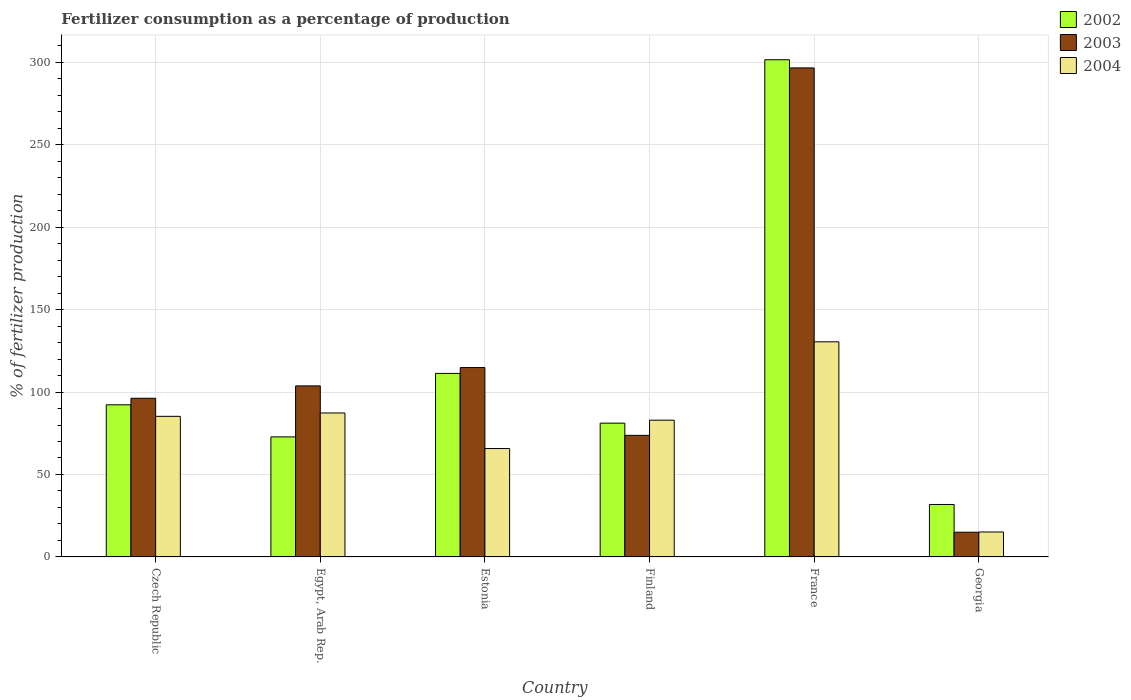How many different coloured bars are there?
Make the answer very short. 3. How many groups of bars are there?
Give a very brief answer. 6. Are the number of bars per tick equal to the number of legend labels?
Provide a succinct answer. Yes. Are the number of bars on each tick of the X-axis equal?
Your answer should be very brief. Yes. How many bars are there on the 1st tick from the left?
Provide a succinct answer. 3. What is the label of the 1st group of bars from the left?
Your response must be concise. Czech Republic. In how many cases, is the number of bars for a given country not equal to the number of legend labels?
Provide a succinct answer. 0. What is the percentage of fertilizers consumed in 2004 in Georgia?
Provide a succinct answer. 15.12. Across all countries, what is the maximum percentage of fertilizers consumed in 2004?
Offer a terse response. 130.46. Across all countries, what is the minimum percentage of fertilizers consumed in 2004?
Offer a very short reply. 15.12. In which country was the percentage of fertilizers consumed in 2002 maximum?
Provide a succinct answer. France. In which country was the percentage of fertilizers consumed in 2003 minimum?
Make the answer very short. Georgia. What is the total percentage of fertilizers consumed in 2002 in the graph?
Give a very brief answer. 690.84. What is the difference between the percentage of fertilizers consumed in 2003 in Egypt, Arab Rep. and that in Estonia?
Ensure brevity in your answer.  -11.13. What is the difference between the percentage of fertilizers consumed in 2004 in Czech Republic and the percentage of fertilizers consumed in 2003 in France?
Your answer should be compact. -211.3. What is the average percentage of fertilizers consumed in 2004 per country?
Your answer should be very brief. 77.8. What is the difference between the percentage of fertilizers consumed of/in 2004 and percentage of fertilizers consumed of/in 2002 in Finland?
Your answer should be very brief. 1.79. In how many countries, is the percentage of fertilizers consumed in 2004 greater than 280 %?
Your answer should be very brief. 0. What is the ratio of the percentage of fertilizers consumed in 2004 in Egypt, Arab Rep. to that in Estonia?
Make the answer very short. 1.33. What is the difference between the highest and the second highest percentage of fertilizers consumed in 2004?
Your response must be concise. 45.19. What is the difference between the highest and the lowest percentage of fertilizers consumed in 2002?
Your answer should be compact. 269.72. Is the sum of the percentage of fertilizers consumed in 2004 in Egypt, Arab Rep. and Finland greater than the maximum percentage of fertilizers consumed in 2003 across all countries?
Ensure brevity in your answer.  No. What does the 3rd bar from the left in Czech Republic represents?
Keep it short and to the point. 2004. What does the 3rd bar from the right in Czech Republic represents?
Offer a very short reply. 2002. Is it the case that in every country, the sum of the percentage of fertilizers consumed in 2002 and percentage of fertilizers consumed in 2003 is greater than the percentage of fertilizers consumed in 2004?
Offer a very short reply. Yes. Are all the bars in the graph horizontal?
Keep it short and to the point. No. How many countries are there in the graph?
Make the answer very short. 6. Are the values on the major ticks of Y-axis written in scientific E-notation?
Make the answer very short. No. Where does the legend appear in the graph?
Keep it short and to the point. Top right. How many legend labels are there?
Your response must be concise. 3. What is the title of the graph?
Offer a very short reply. Fertilizer consumption as a percentage of production. What is the label or title of the Y-axis?
Your response must be concise. % of fertilizer production. What is the % of fertilizer production of 2002 in Czech Republic?
Offer a terse response. 92.26. What is the % of fertilizer production of 2003 in Czech Republic?
Your answer should be very brief. 96.22. What is the % of fertilizer production in 2004 in Czech Republic?
Your answer should be very brief. 85.27. What is the % of fertilizer production of 2002 in Egypt, Arab Rep.?
Offer a very short reply. 72.8. What is the % of fertilizer production in 2003 in Egypt, Arab Rep.?
Make the answer very short. 103.72. What is the % of fertilizer production in 2004 in Egypt, Arab Rep.?
Ensure brevity in your answer.  87.3. What is the % of fertilizer production of 2002 in Estonia?
Make the answer very short. 111.3. What is the % of fertilizer production of 2003 in Estonia?
Offer a terse response. 114.85. What is the % of fertilizer production of 2004 in Estonia?
Provide a succinct answer. 65.74. What is the % of fertilizer production in 2002 in Finland?
Your answer should be compact. 81.14. What is the % of fertilizer production in 2003 in Finland?
Offer a very short reply. 73.73. What is the % of fertilizer production of 2004 in Finland?
Ensure brevity in your answer.  82.93. What is the % of fertilizer production of 2002 in France?
Offer a very short reply. 301.53. What is the % of fertilizer production in 2003 in France?
Your response must be concise. 296.56. What is the % of fertilizer production of 2004 in France?
Offer a terse response. 130.46. What is the % of fertilizer production of 2002 in Georgia?
Your answer should be compact. 31.81. What is the % of fertilizer production of 2003 in Georgia?
Make the answer very short. 14.99. What is the % of fertilizer production of 2004 in Georgia?
Offer a very short reply. 15.12. Across all countries, what is the maximum % of fertilizer production of 2002?
Your response must be concise. 301.53. Across all countries, what is the maximum % of fertilizer production of 2003?
Provide a short and direct response. 296.56. Across all countries, what is the maximum % of fertilizer production in 2004?
Your answer should be compact. 130.46. Across all countries, what is the minimum % of fertilizer production in 2002?
Give a very brief answer. 31.81. Across all countries, what is the minimum % of fertilizer production of 2003?
Offer a very short reply. 14.99. Across all countries, what is the minimum % of fertilizer production of 2004?
Give a very brief answer. 15.12. What is the total % of fertilizer production of 2002 in the graph?
Provide a succinct answer. 690.84. What is the total % of fertilizer production of 2003 in the graph?
Make the answer very short. 700.07. What is the total % of fertilizer production of 2004 in the graph?
Offer a terse response. 466.82. What is the difference between the % of fertilizer production of 2002 in Czech Republic and that in Egypt, Arab Rep.?
Provide a short and direct response. 19.47. What is the difference between the % of fertilizer production of 2003 in Czech Republic and that in Egypt, Arab Rep.?
Your answer should be compact. -7.5. What is the difference between the % of fertilizer production in 2004 in Czech Republic and that in Egypt, Arab Rep.?
Make the answer very short. -2.03. What is the difference between the % of fertilizer production in 2002 in Czech Republic and that in Estonia?
Offer a very short reply. -19.04. What is the difference between the % of fertilizer production of 2003 in Czech Republic and that in Estonia?
Offer a terse response. -18.63. What is the difference between the % of fertilizer production of 2004 in Czech Republic and that in Estonia?
Your answer should be very brief. 19.53. What is the difference between the % of fertilizer production of 2002 in Czech Republic and that in Finland?
Your answer should be compact. 11.12. What is the difference between the % of fertilizer production in 2003 in Czech Republic and that in Finland?
Your answer should be very brief. 22.49. What is the difference between the % of fertilizer production in 2004 in Czech Republic and that in Finland?
Give a very brief answer. 2.34. What is the difference between the % of fertilizer production of 2002 in Czech Republic and that in France?
Provide a short and direct response. -209.27. What is the difference between the % of fertilizer production in 2003 in Czech Republic and that in France?
Give a very brief answer. -200.34. What is the difference between the % of fertilizer production in 2004 in Czech Republic and that in France?
Your answer should be compact. -45.19. What is the difference between the % of fertilizer production in 2002 in Czech Republic and that in Georgia?
Your answer should be very brief. 60.45. What is the difference between the % of fertilizer production of 2003 in Czech Republic and that in Georgia?
Provide a succinct answer. 81.24. What is the difference between the % of fertilizer production of 2004 in Czech Republic and that in Georgia?
Make the answer very short. 70.15. What is the difference between the % of fertilizer production in 2002 in Egypt, Arab Rep. and that in Estonia?
Give a very brief answer. -38.51. What is the difference between the % of fertilizer production of 2003 in Egypt, Arab Rep. and that in Estonia?
Provide a succinct answer. -11.13. What is the difference between the % of fertilizer production in 2004 in Egypt, Arab Rep. and that in Estonia?
Your answer should be very brief. 21.56. What is the difference between the % of fertilizer production of 2002 in Egypt, Arab Rep. and that in Finland?
Ensure brevity in your answer.  -8.34. What is the difference between the % of fertilizer production of 2003 in Egypt, Arab Rep. and that in Finland?
Make the answer very short. 29.99. What is the difference between the % of fertilizer production in 2004 in Egypt, Arab Rep. and that in Finland?
Keep it short and to the point. 4.37. What is the difference between the % of fertilizer production of 2002 in Egypt, Arab Rep. and that in France?
Ensure brevity in your answer.  -228.73. What is the difference between the % of fertilizer production of 2003 in Egypt, Arab Rep. and that in France?
Give a very brief answer. -192.85. What is the difference between the % of fertilizer production in 2004 in Egypt, Arab Rep. and that in France?
Your answer should be compact. -43.16. What is the difference between the % of fertilizer production of 2002 in Egypt, Arab Rep. and that in Georgia?
Provide a short and direct response. 40.99. What is the difference between the % of fertilizer production of 2003 in Egypt, Arab Rep. and that in Georgia?
Offer a terse response. 88.73. What is the difference between the % of fertilizer production of 2004 in Egypt, Arab Rep. and that in Georgia?
Ensure brevity in your answer.  72.18. What is the difference between the % of fertilizer production of 2002 in Estonia and that in Finland?
Your answer should be very brief. 30.17. What is the difference between the % of fertilizer production in 2003 in Estonia and that in Finland?
Offer a very short reply. 41.12. What is the difference between the % of fertilizer production of 2004 in Estonia and that in Finland?
Provide a short and direct response. -17.19. What is the difference between the % of fertilizer production of 2002 in Estonia and that in France?
Offer a very short reply. -190.22. What is the difference between the % of fertilizer production in 2003 in Estonia and that in France?
Your answer should be very brief. -181.71. What is the difference between the % of fertilizer production in 2004 in Estonia and that in France?
Make the answer very short. -64.72. What is the difference between the % of fertilizer production of 2002 in Estonia and that in Georgia?
Offer a very short reply. 79.5. What is the difference between the % of fertilizer production of 2003 in Estonia and that in Georgia?
Offer a terse response. 99.86. What is the difference between the % of fertilizer production in 2004 in Estonia and that in Georgia?
Offer a very short reply. 50.62. What is the difference between the % of fertilizer production in 2002 in Finland and that in France?
Provide a succinct answer. -220.39. What is the difference between the % of fertilizer production in 2003 in Finland and that in France?
Your response must be concise. -222.83. What is the difference between the % of fertilizer production in 2004 in Finland and that in France?
Provide a short and direct response. -47.53. What is the difference between the % of fertilizer production in 2002 in Finland and that in Georgia?
Provide a succinct answer. 49.33. What is the difference between the % of fertilizer production of 2003 in Finland and that in Georgia?
Give a very brief answer. 58.75. What is the difference between the % of fertilizer production in 2004 in Finland and that in Georgia?
Provide a succinct answer. 67.81. What is the difference between the % of fertilizer production in 2002 in France and that in Georgia?
Provide a short and direct response. 269.72. What is the difference between the % of fertilizer production in 2003 in France and that in Georgia?
Provide a short and direct response. 281.58. What is the difference between the % of fertilizer production of 2004 in France and that in Georgia?
Give a very brief answer. 115.34. What is the difference between the % of fertilizer production of 2002 in Czech Republic and the % of fertilizer production of 2003 in Egypt, Arab Rep.?
Give a very brief answer. -11.46. What is the difference between the % of fertilizer production in 2002 in Czech Republic and the % of fertilizer production in 2004 in Egypt, Arab Rep.?
Give a very brief answer. 4.96. What is the difference between the % of fertilizer production of 2003 in Czech Republic and the % of fertilizer production of 2004 in Egypt, Arab Rep.?
Provide a succinct answer. 8.92. What is the difference between the % of fertilizer production of 2002 in Czech Republic and the % of fertilizer production of 2003 in Estonia?
Your answer should be compact. -22.59. What is the difference between the % of fertilizer production in 2002 in Czech Republic and the % of fertilizer production in 2004 in Estonia?
Your response must be concise. 26.52. What is the difference between the % of fertilizer production of 2003 in Czech Republic and the % of fertilizer production of 2004 in Estonia?
Ensure brevity in your answer.  30.48. What is the difference between the % of fertilizer production of 2002 in Czech Republic and the % of fertilizer production of 2003 in Finland?
Your answer should be compact. 18.53. What is the difference between the % of fertilizer production of 2002 in Czech Republic and the % of fertilizer production of 2004 in Finland?
Offer a very short reply. 9.33. What is the difference between the % of fertilizer production of 2003 in Czech Republic and the % of fertilizer production of 2004 in Finland?
Your response must be concise. 13.29. What is the difference between the % of fertilizer production of 2002 in Czech Republic and the % of fertilizer production of 2003 in France?
Give a very brief answer. -204.3. What is the difference between the % of fertilizer production of 2002 in Czech Republic and the % of fertilizer production of 2004 in France?
Give a very brief answer. -38.2. What is the difference between the % of fertilizer production of 2003 in Czech Republic and the % of fertilizer production of 2004 in France?
Your answer should be very brief. -34.24. What is the difference between the % of fertilizer production in 2002 in Czech Republic and the % of fertilizer production in 2003 in Georgia?
Provide a succinct answer. 77.28. What is the difference between the % of fertilizer production of 2002 in Czech Republic and the % of fertilizer production of 2004 in Georgia?
Provide a short and direct response. 77.14. What is the difference between the % of fertilizer production in 2003 in Czech Republic and the % of fertilizer production in 2004 in Georgia?
Offer a very short reply. 81.1. What is the difference between the % of fertilizer production of 2002 in Egypt, Arab Rep. and the % of fertilizer production of 2003 in Estonia?
Offer a terse response. -42.05. What is the difference between the % of fertilizer production of 2002 in Egypt, Arab Rep. and the % of fertilizer production of 2004 in Estonia?
Ensure brevity in your answer.  7.06. What is the difference between the % of fertilizer production of 2003 in Egypt, Arab Rep. and the % of fertilizer production of 2004 in Estonia?
Make the answer very short. 37.98. What is the difference between the % of fertilizer production in 2002 in Egypt, Arab Rep. and the % of fertilizer production in 2003 in Finland?
Ensure brevity in your answer.  -0.94. What is the difference between the % of fertilizer production in 2002 in Egypt, Arab Rep. and the % of fertilizer production in 2004 in Finland?
Provide a short and direct response. -10.14. What is the difference between the % of fertilizer production of 2003 in Egypt, Arab Rep. and the % of fertilizer production of 2004 in Finland?
Ensure brevity in your answer.  20.79. What is the difference between the % of fertilizer production in 2002 in Egypt, Arab Rep. and the % of fertilizer production in 2003 in France?
Ensure brevity in your answer.  -223.77. What is the difference between the % of fertilizer production in 2002 in Egypt, Arab Rep. and the % of fertilizer production in 2004 in France?
Your answer should be compact. -57.66. What is the difference between the % of fertilizer production of 2003 in Egypt, Arab Rep. and the % of fertilizer production of 2004 in France?
Offer a terse response. -26.74. What is the difference between the % of fertilizer production in 2002 in Egypt, Arab Rep. and the % of fertilizer production in 2003 in Georgia?
Offer a very short reply. 57.81. What is the difference between the % of fertilizer production in 2002 in Egypt, Arab Rep. and the % of fertilizer production in 2004 in Georgia?
Ensure brevity in your answer.  57.68. What is the difference between the % of fertilizer production of 2003 in Egypt, Arab Rep. and the % of fertilizer production of 2004 in Georgia?
Offer a very short reply. 88.6. What is the difference between the % of fertilizer production of 2002 in Estonia and the % of fertilizer production of 2003 in Finland?
Your answer should be compact. 37.57. What is the difference between the % of fertilizer production of 2002 in Estonia and the % of fertilizer production of 2004 in Finland?
Your answer should be compact. 28.37. What is the difference between the % of fertilizer production of 2003 in Estonia and the % of fertilizer production of 2004 in Finland?
Ensure brevity in your answer.  31.92. What is the difference between the % of fertilizer production of 2002 in Estonia and the % of fertilizer production of 2003 in France?
Keep it short and to the point. -185.26. What is the difference between the % of fertilizer production of 2002 in Estonia and the % of fertilizer production of 2004 in France?
Your answer should be compact. -19.16. What is the difference between the % of fertilizer production of 2003 in Estonia and the % of fertilizer production of 2004 in France?
Give a very brief answer. -15.61. What is the difference between the % of fertilizer production of 2002 in Estonia and the % of fertilizer production of 2003 in Georgia?
Offer a very short reply. 96.32. What is the difference between the % of fertilizer production of 2002 in Estonia and the % of fertilizer production of 2004 in Georgia?
Provide a succinct answer. 96.19. What is the difference between the % of fertilizer production of 2003 in Estonia and the % of fertilizer production of 2004 in Georgia?
Offer a very short reply. 99.73. What is the difference between the % of fertilizer production in 2002 in Finland and the % of fertilizer production in 2003 in France?
Your answer should be compact. -215.43. What is the difference between the % of fertilizer production of 2002 in Finland and the % of fertilizer production of 2004 in France?
Provide a succinct answer. -49.32. What is the difference between the % of fertilizer production of 2003 in Finland and the % of fertilizer production of 2004 in France?
Provide a short and direct response. -56.73. What is the difference between the % of fertilizer production of 2002 in Finland and the % of fertilizer production of 2003 in Georgia?
Your response must be concise. 66.15. What is the difference between the % of fertilizer production of 2002 in Finland and the % of fertilizer production of 2004 in Georgia?
Offer a terse response. 66.02. What is the difference between the % of fertilizer production of 2003 in Finland and the % of fertilizer production of 2004 in Georgia?
Give a very brief answer. 58.61. What is the difference between the % of fertilizer production in 2002 in France and the % of fertilizer production in 2003 in Georgia?
Ensure brevity in your answer.  286.54. What is the difference between the % of fertilizer production of 2002 in France and the % of fertilizer production of 2004 in Georgia?
Provide a short and direct response. 286.41. What is the difference between the % of fertilizer production in 2003 in France and the % of fertilizer production in 2004 in Georgia?
Your response must be concise. 281.45. What is the average % of fertilizer production in 2002 per country?
Make the answer very short. 115.14. What is the average % of fertilizer production of 2003 per country?
Offer a terse response. 116.68. What is the average % of fertilizer production of 2004 per country?
Your answer should be compact. 77.8. What is the difference between the % of fertilizer production of 2002 and % of fertilizer production of 2003 in Czech Republic?
Make the answer very short. -3.96. What is the difference between the % of fertilizer production of 2002 and % of fertilizer production of 2004 in Czech Republic?
Offer a very short reply. 6.99. What is the difference between the % of fertilizer production in 2003 and % of fertilizer production in 2004 in Czech Republic?
Provide a short and direct response. 10.95. What is the difference between the % of fertilizer production in 2002 and % of fertilizer production in 2003 in Egypt, Arab Rep.?
Make the answer very short. -30.92. What is the difference between the % of fertilizer production of 2002 and % of fertilizer production of 2004 in Egypt, Arab Rep.?
Your answer should be compact. -14.5. What is the difference between the % of fertilizer production in 2003 and % of fertilizer production in 2004 in Egypt, Arab Rep.?
Your response must be concise. 16.42. What is the difference between the % of fertilizer production of 2002 and % of fertilizer production of 2003 in Estonia?
Your response must be concise. -3.55. What is the difference between the % of fertilizer production of 2002 and % of fertilizer production of 2004 in Estonia?
Keep it short and to the point. 45.57. What is the difference between the % of fertilizer production of 2003 and % of fertilizer production of 2004 in Estonia?
Give a very brief answer. 49.11. What is the difference between the % of fertilizer production of 2002 and % of fertilizer production of 2003 in Finland?
Provide a succinct answer. 7.41. What is the difference between the % of fertilizer production in 2002 and % of fertilizer production in 2004 in Finland?
Ensure brevity in your answer.  -1.79. What is the difference between the % of fertilizer production of 2003 and % of fertilizer production of 2004 in Finland?
Offer a terse response. -9.2. What is the difference between the % of fertilizer production of 2002 and % of fertilizer production of 2003 in France?
Ensure brevity in your answer.  4.96. What is the difference between the % of fertilizer production of 2002 and % of fertilizer production of 2004 in France?
Offer a very short reply. 171.07. What is the difference between the % of fertilizer production of 2003 and % of fertilizer production of 2004 in France?
Your answer should be compact. 166.1. What is the difference between the % of fertilizer production of 2002 and % of fertilizer production of 2003 in Georgia?
Give a very brief answer. 16.82. What is the difference between the % of fertilizer production in 2002 and % of fertilizer production in 2004 in Georgia?
Your response must be concise. 16.69. What is the difference between the % of fertilizer production of 2003 and % of fertilizer production of 2004 in Georgia?
Ensure brevity in your answer.  -0.13. What is the ratio of the % of fertilizer production in 2002 in Czech Republic to that in Egypt, Arab Rep.?
Your response must be concise. 1.27. What is the ratio of the % of fertilizer production in 2003 in Czech Republic to that in Egypt, Arab Rep.?
Offer a very short reply. 0.93. What is the ratio of the % of fertilizer production in 2004 in Czech Republic to that in Egypt, Arab Rep.?
Make the answer very short. 0.98. What is the ratio of the % of fertilizer production of 2002 in Czech Republic to that in Estonia?
Your response must be concise. 0.83. What is the ratio of the % of fertilizer production in 2003 in Czech Republic to that in Estonia?
Provide a short and direct response. 0.84. What is the ratio of the % of fertilizer production in 2004 in Czech Republic to that in Estonia?
Your answer should be very brief. 1.3. What is the ratio of the % of fertilizer production of 2002 in Czech Republic to that in Finland?
Your response must be concise. 1.14. What is the ratio of the % of fertilizer production in 2003 in Czech Republic to that in Finland?
Make the answer very short. 1.3. What is the ratio of the % of fertilizer production of 2004 in Czech Republic to that in Finland?
Make the answer very short. 1.03. What is the ratio of the % of fertilizer production of 2002 in Czech Republic to that in France?
Offer a very short reply. 0.31. What is the ratio of the % of fertilizer production of 2003 in Czech Republic to that in France?
Provide a short and direct response. 0.32. What is the ratio of the % of fertilizer production of 2004 in Czech Republic to that in France?
Make the answer very short. 0.65. What is the ratio of the % of fertilizer production in 2002 in Czech Republic to that in Georgia?
Ensure brevity in your answer.  2.9. What is the ratio of the % of fertilizer production of 2003 in Czech Republic to that in Georgia?
Your response must be concise. 6.42. What is the ratio of the % of fertilizer production in 2004 in Czech Republic to that in Georgia?
Your answer should be compact. 5.64. What is the ratio of the % of fertilizer production in 2002 in Egypt, Arab Rep. to that in Estonia?
Offer a terse response. 0.65. What is the ratio of the % of fertilizer production in 2003 in Egypt, Arab Rep. to that in Estonia?
Make the answer very short. 0.9. What is the ratio of the % of fertilizer production in 2004 in Egypt, Arab Rep. to that in Estonia?
Make the answer very short. 1.33. What is the ratio of the % of fertilizer production in 2002 in Egypt, Arab Rep. to that in Finland?
Make the answer very short. 0.9. What is the ratio of the % of fertilizer production of 2003 in Egypt, Arab Rep. to that in Finland?
Give a very brief answer. 1.41. What is the ratio of the % of fertilizer production in 2004 in Egypt, Arab Rep. to that in Finland?
Provide a succinct answer. 1.05. What is the ratio of the % of fertilizer production in 2002 in Egypt, Arab Rep. to that in France?
Your response must be concise. 0.24. What is the ratio of the % of fertilizer production of 2003 in Egypt, Arab Rep. to that in France?
Make the answer very short. 0.35. What is the ratio of the % of fertilizer production in 2004 in Egypt, Arab Rep. to that in France?
Offer a very short reply. 0.67. What is the ratio of the % of fertilizer production of 2002 in Egypt, Arab Rep. to that in Georgia?
Your answer should be very brief. 2.29. What is the ratio of the % of fertilizer production of 2003 in Egypt, Arab Rep. to that in Georgia?
Provide a succinct answer. 6.92. What is the ratio of the % of fertilizer production in 2004 in Egypt, Arab Rep. to that in Georgia?
Ensure brevity in your answer.  5.77. What is the ratio of the % of fertilizer production of 2002 in Estonia to that in Finland?
Give a very brief answer. 1.37. What is the ratio of the % of fertilizer production of 2003 in Estonia to that in Finland?
Offer a terse response. 1.56. What is the ratio of the % of fertilizer production of 2004 in Estonia to that in Finland?
Provide a succinct answer. 0.79. What is the ratio of the % of fertilizer production of 2002 in Estonia to that in France?
Keep it short and to the point. 0.37. What is the ratio of the % of fertilizer production in 2003 in Estonia to that in France?
Ensure brevity in your answer.  0.39. What is the ratio of the % of fertilizer production in 2004 in Estonia to that in France?
Provide a short and direct response. 0.5. What is the ratio of the % of fertilizer production in 2002 in Estonia to that in Georgia?
Provide a succinct answer. 3.5. What is the ratio of the % of fertilizer production in 2003 in Estonia to that in Georgia?
Provide a succinct answer. 7.66. What is the ratio of the % of fertilizer production of 2004 in Estonia to that in Georgia?
Your answer should be very brief. 4.35. What is the ratio of the % of fertilizer production in 2002 in Finland to that in France?
Your answer should be very brief. 0.27. What is the ratio of the % of fertilizer production of 2003 in Finland to that in France?
Your answer should be compact. 0.25. What is the ratio of the % of fertilizer production of 2004 in Finland to that in France?
Keep it short and to the point. 0.64. What is the ratio of the % of fertilizer production of 2002 in Finland to that in Georgia?
Give a very brief answer. 2.55. What is the ratio of the % of fertilizer production in 2003 in Finland to that in Georgia?
Provide a succinct answer. 4.92. What is the ratio of the % of fertilizer production of 2004 in Finland to that in Georgia?
Your answer should be very brief. 5.49. What is the ratio of the % of fertilizer production of 2002 in France to that in Georgia?
Make the answer very short. 9.48. What is the ratio of the % of fertilizer production of 2003 in France to that in Georgia?
Make the answer very short. 19.79. What is the ratio of the % of fertilizer production of 2004 in France to that in Georgia?
Make the answer very short. 8.63. What is the difference between the highest and the second highest % of fertilizer production of 2002?
Provide a short and direct response. 190.22. What is the difference between the highest and the second highest % of fertilizer production in 2003?
Provide a short and direct response. 181.71. What is the difference between the highest and the second highest % of fertilizer production in 2004?
Give a very brief answer. 43.16. What is the difference between the highest and the lowest % of fertilizer production in 2002?
Your response must be concise. 269.72. What is the difference between the highest and the lowest % of fertilizer production in 2003?
Give a very brief answer. 281.58. What is the difference between the highest and the lowest % of fertilizer production of 2004?
Give a very brief answer. 115.34. 